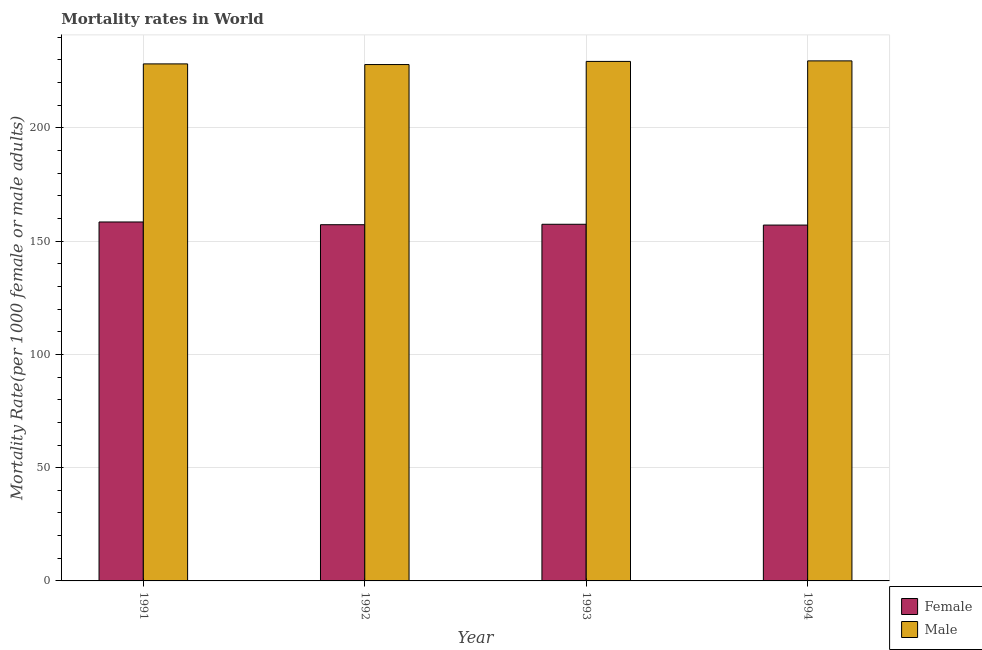Are the number of bars per tick equal to the number of legend labels?
Your response must be concise. Yes. How many bars are there on the 2nd tick from the right?
Provide a short and direct response. 2. What is the label of the 2nd group of bars from the left?
Your answer should be very brief. 1992. What is the male mortality rate in 1991?
Your answer should be compact. 228.25. Across all years, what is the maximum male mortality rate?
Give a very brief answer. 229.58. Across all years, what is the minimum female mortality rate?
Your answer should be compact. 157.1. In which year was the male mortality rate minimum?
Provide a short and direct response. 1992. What is the total female mortality rate in the graph?
Offer a terse response. 630.26. What is the difference between the female mortality rate in 1993 and that in 1994?
Offer a very short reply. 0.35. What is the difference between the female mortality rate in 1991 and the male mortality rate in 1994?
Your answer should be very brief. 1.37. What is the average female mortality rate per year?
Give a very brief answer. 157.57. In the year 1992, what is the difference between the female mortality rate and male mortality rate?
Offer a terse response. 0. What is the ratio of the male mortality rate in 1993 to that in 1994?
Provide a short and direct response. 1. Is the male mortality rate in 1992 less than that in 1993?
Offer a very short reply. Yes. Is the difference between the male mortality rate in 1991 and 1994 greater than the difference between the female mortality rate in 1991 and 1994?
Provide a succinct answer. No. What is the difference between the highest and the second highest female mortality rate?
Your answer should be very brief. 1.02. What is the difference between the highest and the lowest male mortality rate?
Provide a succinct answer. 1.63. In how many years, is the female mortality rate greater than the average female mortality rate taken over all years?
Your response must be concise. 1. Is the sum of the female mortality rate in 1993 and 1994 greater than the maximum male mortality rate across all years?
Give a very brief answer. Yes. How many bars are there?
Your response must be concise. 8. Are all the bars in the graph horizontal?
Your response must be concise. No. How many legend labels are there?
Keep it short and to the point. 2. How are the legend labels stacked?
Give a very brief answer. Vertical. What is the title of the graph?
Make the answer very short. Mortality rates in World. Does "Goods" appear as one of the legend labels in the graph?
Ensure brevity in your answer.  No. What is the label or title of the X-axis?
Offer a very short reply. Year. What is the label or title of the Y-axis?
Provide a short and direct response. Mortality Rate(per 1000 female or male adults). What is the Mortality Rate(per 1000 female or male adults) in Female in 1991?
Keep it short and to the point. 158.46. What is the Mortality Rate(per 1000 female or male adults) in Male in 1991?
Make the answer very short. 228.25. What is the Mortality Rate(per 1000 female or male adults) in Female in 1992?
Your response must be concise. 157.25. What is the Mortality Rate(per 1000 female or male adults) in Male in 1992?
Provide a succinct answer. 227.96. What is the Mortality Rate(per 1000 female or male adults) of Female in 1993?
Provide a succinct answer. 157.45. What is the Mortality Rate(per 1000 female or male adults) in Male in 1993?
Your answer should be compact. 229.34. What is the Mortality Rate(per 1000 female or male adults) in Female in 1994?
Provide a succinct answer. 157.1. What is the Mortality Rate(per 1000 female or male adults) in Male in 1994?
Your answer should be compact. 229.58. Across all years, what is the maximum Mortality Rate(per 1000 female or male adults) of Female?
Offer a very short reply. 158.46. Across all years, what is the maximum Mortality Rate(per 1000 female or male adults) of Male?
Your answer should be compact. 229.58. Across all years, what is the minimum Mortality Rate(per 1000 female or male adults) in Female?
Offer a terse response. 157.1. Across all years, what is the minimum Mortality Rate(per 1000 female or male adults) of Male?
Offer a terse response. 227.96. What is the total Mortality Rate(per 1000 female or male adults) of Female in the graph?
Your answer should be compact. 630.26. What is the total Mortality Rate(per 1000 female or male adults) of Male in the graph?
Make the answer very short. 915.13. What is the difference between the Mortality Rate(per 1000 female or male adults) of Female in 1991 and that in 1992?
Give a very brief answer. 1.21. What is the difference between the Mortality Rate(per 1000 female or male adults) of Male in 1991 and that in 1992?
Offer a very short reply. 0.29. What is the difference between the Mortality Rate(per 1000 female or male adults) in Female in 1991 and that in 1993?
Provide a short and direct response. 1.02. What is the difference between the Mortality Rate(per 1000 female or male adults) of Male in 1991 and that in 1993?
Offer a very short reply. -1.09. What is the difference between the Mortality Rate(per 1000 female or male adults) in Female in 1991 and that in 1994?
Offer a terse response. 1.37. What is the difference between the Mortality Rate(per 1000 female or male adults) in Male in 1991 and that in 1994?
Your response must be concise. -1.33. What is the difference between the Mortality Rate(per 1000 female or male adults) in Female in 1992 and that in 1993?
Make the answer very short. -0.2. What is the difference between the Mortality Rate(per 1000 female or male adults) in Male in 1992 and that in 1993?
Your response must be concise. -1.39. What is the difference between the Mortality Rate(per 1000 female or male adults) in Female in 1992 and that in 1994?
Your answer should be very brief. 0.15. What is the difference between the Mortality Rate(per 1000 female or male adults) in Male in 1992 and that in 1994?
Offer a very short reply. -1.63. What is the difference between the Mortality Rate(per 1000 female or male adults) in Female in 1993 and that in 1994?
Ensure brevity in your answer.  0.35. What is the difference between the Mortality Rate(per 1000 female or male adults) in Male in 1993 and that in 1994?
Your answer should be compact. -0.24. What is the difference between the Mortality Rate(per 1000 female or male adults) in Female in 1991 and the Mortality Rate(per 1000 female or male adults) in Male in 1992?
Give a very brief answer. -69.49. What is the difference between the Mortality Rate(per 1000 female or male adults) in Female in 1991 and the Mortality Rate(per 1000 female or male adults) in Male in 1993?
Offer a very short reply. -70.88. What is the difference between the Mortality Rate(per 1000 female or male adults) of Female in 1991 and the Mortality Rate(per 1000 female or male adults) of Male in 1994?
Provide a succinct answer. -71.12. What is the difference between the Mortality Rate(per 1000 female or male adults) in Female in 1992 and the Mortality Rate(per 1000 female or male adults) in Male in 1993?
Your answer should be very brief. -72.09. What is the difference between the Mortality Rate(per 1000 female or male adults) in Female in 1992 and the Mortality Rate(per 1000 female or male adults) in Male in 1994?
Provide a succinct answer. -72.33. What is the difference between the Mortality Rate(per 1000 female or male adults) of Female in 1993 and the Mortality Rate(per 1000 female or male adults) of Male in 1994?
Make the answer very short. -72.13. What is the average Mortality Rate(per 1000 female or male adults) in Female per year?
Offer a terse response. 157.57. What is the average Mortality Rate(per 1000 female or male adults) in Male per year?
Ensure brevity in your answer.  228.78. In the year 1991, what is the difference between the Mortality Rate(per 1000 female or male adults) in Female and Mortality Rate(per 1000 female or male adults) in Male?
Give a very brief answer. -69.79. In the year 1992, what is the difference between the Mortality Rate(per 1000 female or male adults) in Female and Mortality Rate(per 1000 female or male adults) in Male?
Provide a succinct answer. -70.7. In the year 1993, what is the difference between the Mortality Rate(per 1000 female or male adults) in Female and Mortality Rate(per 1000 female or male adults) in Male?
Provide a succinct answer. -71.9. In the year 1994, what is the difference between the Mortality Rate(per 1000 female or male adults) in Female and Mortality Rate(per 1000 female or male adults) in Male?
Your response must be concise. -72.48. What is the ratio of the Mortality Rate(per 1000 female or male adults) in Female in 1991 to that in 1992?
Provide a short and direct response. 1.01. What is the ratio of the Mortality Rate(per 1000 female or male adults) of Male in 1991 to that in 1992?
Your answer should be very brief. 1. What is the ratio of the Mortality Rate(per 1000 female or male adults) of Female in 1991 to that in 1993?
Your response must be concise. 1.01. What is the ratio of the Mortality Rate(per 1000 female or male adults) in Female in 1991 to that in 1994?
Provide a short and direct response. 1.01. What is the ratio of the Mortality Rate(per 1000 female or male adults) of Female in 1992 to that in 1993?
Offer a very short reply. 1. What is the ratio of the Mortality Rate(per 1000 female or male adults) in Male in 1992 to that in 1994?
Your answer should be compact. 0.99. What is the ratio of the Mortality Rate(per 1000 female or male adults) in Female in 1993 to that in 1994?
Make the answer very short. 1. What is the difference between the highest and the second highest Mortality Rate(per 1000 female or male adults) of Male?
Provide a short and direct response. 0.24. What is the difference between the highest and the lowest Mortality Rate(per 1000 female or male adults) in Female?
Make the answer very short. 1.37. What is the difference between the highest and the lowest Mortality Rate(per 1000 female or male adults) of Male?
Your answer should be compact. 1.63. 